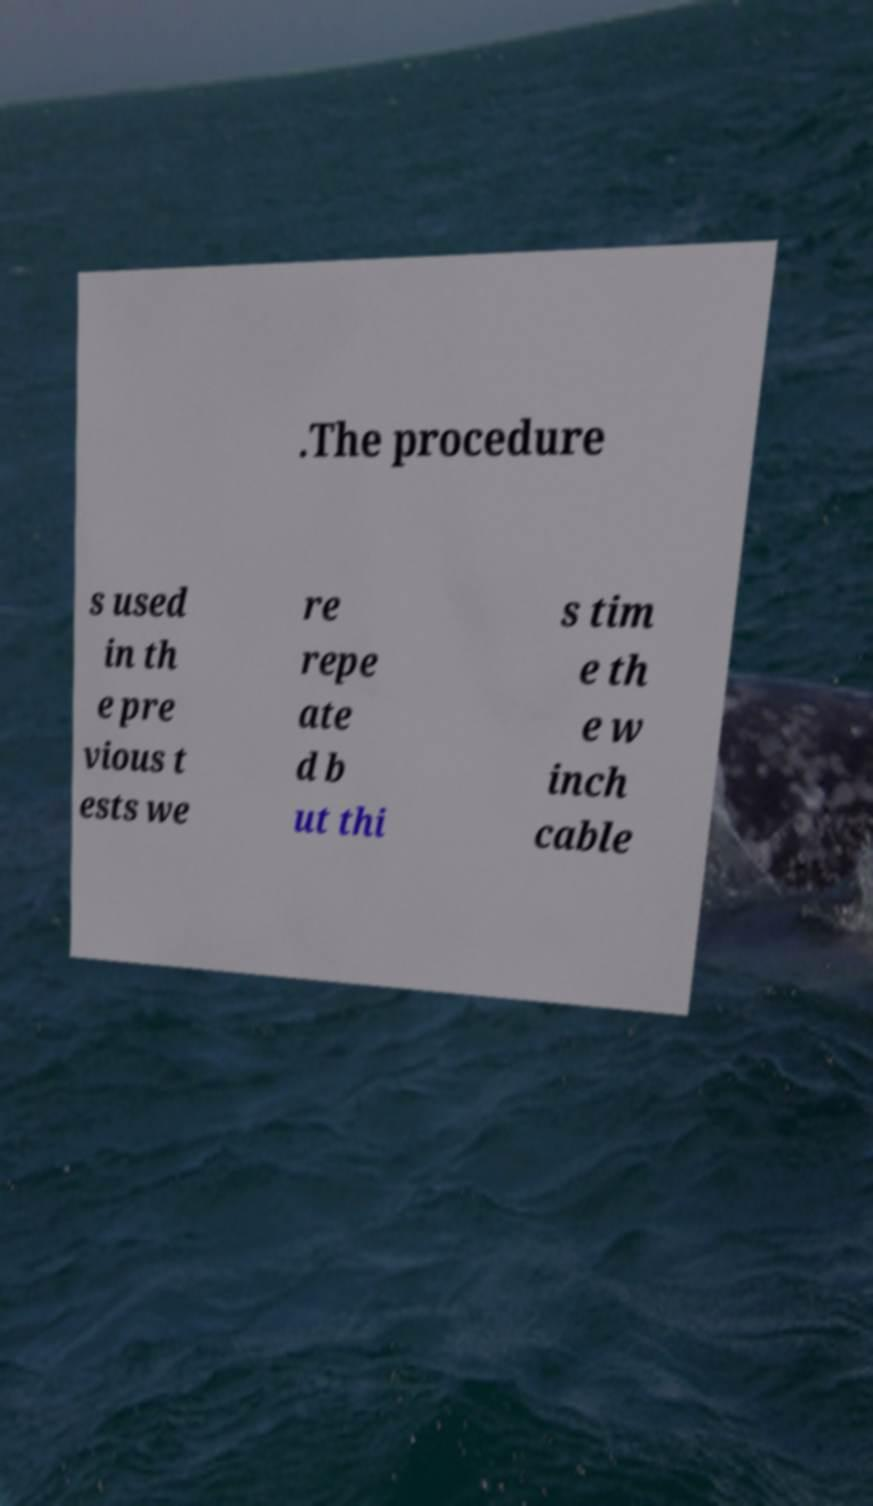Please read and relay the text visible in this image. What does it say? .The procedure s used in th e pre vious t ests we re repe ate d b ut thi s tim e th e w inch cable 